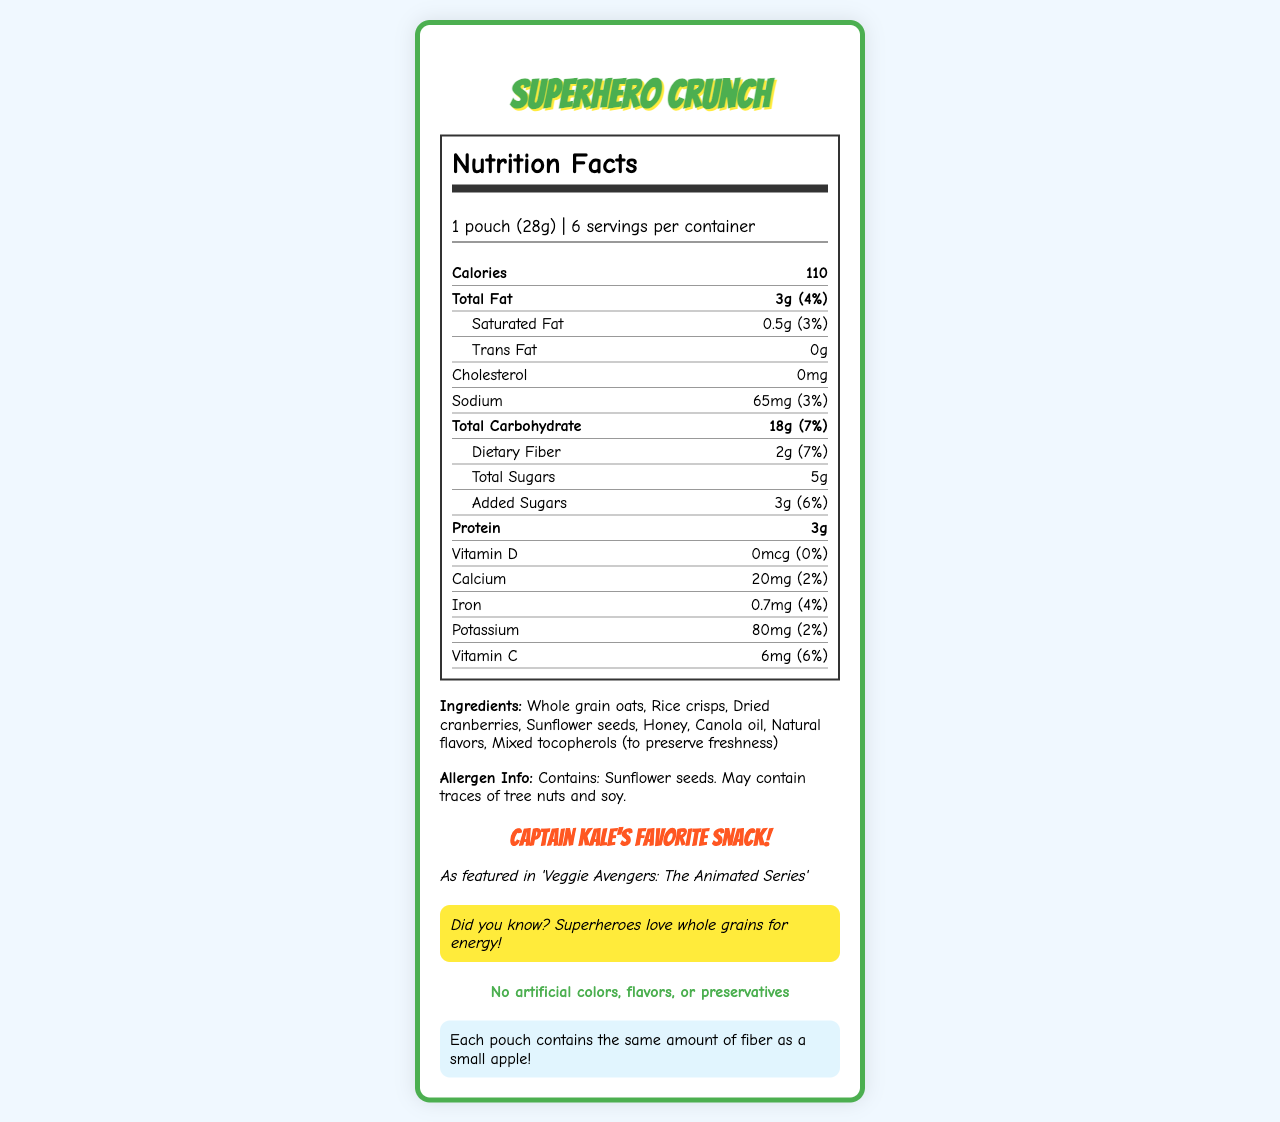**Short-answer:**
1. What is the serving size of Superhero Crunch? The serving size is clearly listed as "1 pouch (28g)" in the document.
Answer: 1 pouch (28g) 2. How many calories are in one serving of Superhero Crunch? The document states that there are 110 calories per serving.
Answer: 110 3. What is the amount of dietary fiber per serving? The document indicates there are 2g of dietary fiber per serving.
Answer: 2g 4. Which TV show features Superhero Crunch? The document mentions that it is featured in 'Veggie Avengers: The Animated Series'.
Answer: 'Veggie Avengers: The Animated Series' 5. What are the main ingredients in Superhero Crunch? These ingredients are listed under the "Ingredients" section of the document.
Answer: Whole grain oats, Rice crisps, Dried cranberries, Sunflower seeds, Honey, Canola oil, Natural flavors, Mixed tocopherols (to preserve freshness) **Multiple-choice:**
6. What is the daily value percentage of iron in Superhero Crunch? A. 2% B. 4% C. 6% D. 8% The document states that the daily value percentage of iron is 4%.
Answer: B. 4% 7. Which of the following nutrients does Superhero Crunch NOT contain? I. Trans Fat II. Cholesterol III. Sodium IV. Protein A. I and II B. II and III C. I and IV D. III and IV The document shows that Superhero Crunch contains 0g of Trans Fat and 0mg of Cholesterol.
Answer: A. I and II **Yes/No (True/False):**
8. Does Superhero Crunch contain any added sugars? The document lists added sugars amounting to 3g.
Answer: Yes **Summary:**
9. Summarize the nutritional content and special features of Superhero Crunch. This summary captures the main nutritional values and the special features highlighted in the document.
Answer: Superhero Crunch is a healthy snack with a 28g serving size, containing 110 calories per serving. It includes 3g of total fat, 0.5g of saturated fat, 0g of trans fat, 65mg of sodium, 18g of total carbohydrates, 2g of dietary fiber, 5g of total sugars (with 3g of added sugars), and 3g of protein. It does not have any cholesterol or vitamin D. It contains some vitamins and minerals such as calcium, iron, potassium, and vitamin C. The ingredients are whole grain oats, rice crisps, dried cranberries, sunflower seeds, honey, canola oil, natural flavors, and mixed tocopherols. It is endorsed by Captain Kale and featured in the TV show 'Veggie Avengers: The Animated Series'. The snack has no artificial colors, flavors, or preservatives. **Unanswerable:**
10. What is the price of a container of Superhero Crunch? The document does not provide any pricing information.
Answer: Not enough information 